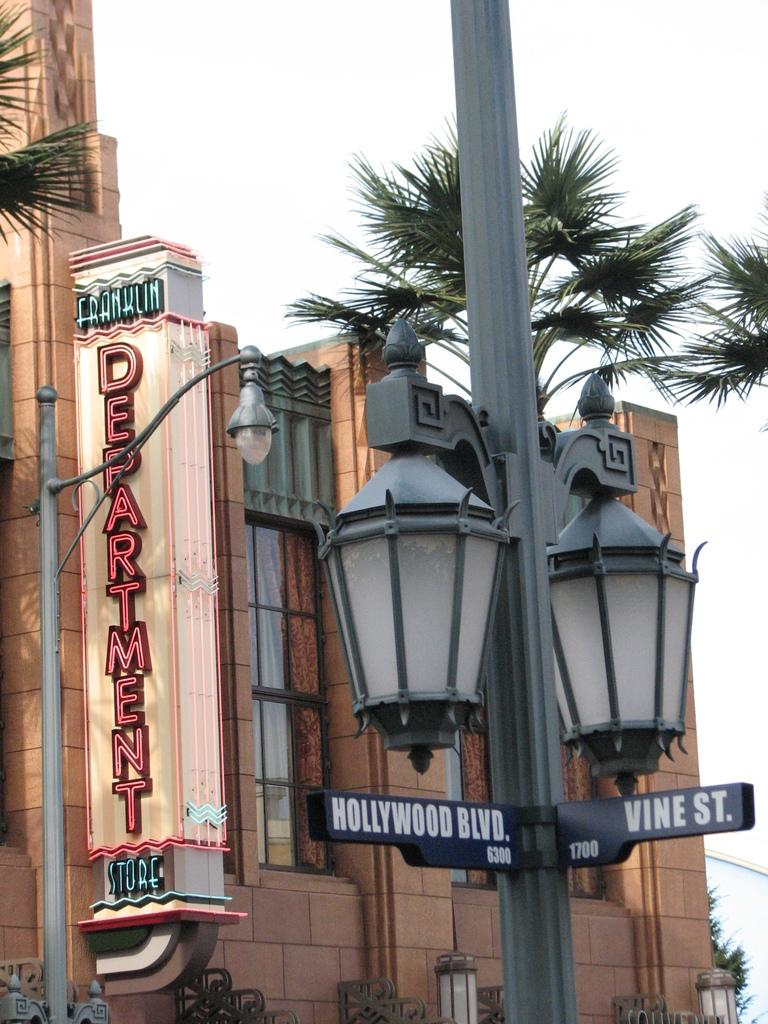What is located in the foreground of the image? There is a light pole in the foreground of the image. What can be seen in the background of the image? There is a building and trees in the background of the image. What is visible in the sky in the image? The sky is visible in the image. What arithmetic problem is being solved on the light pole in the image? There is no arithmetic problem present on the light pole in the image. Can you see a plane flying in the sky in the image? There is no plane visible in the sky in the image. 